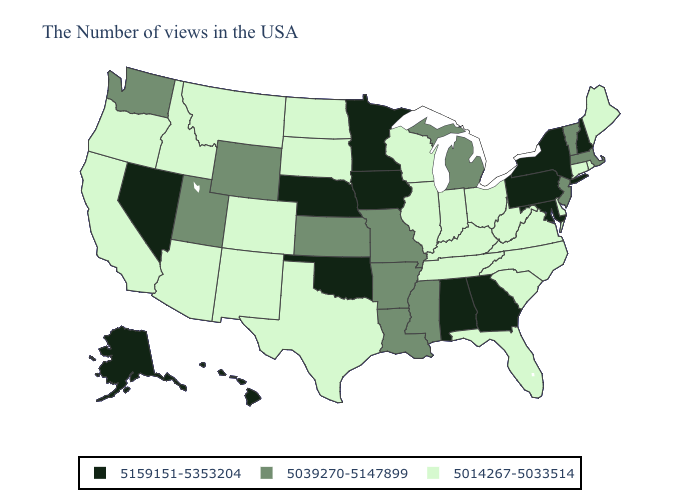Among the states that border Delaware , does Pennsylvania have the highest value?
Be succinct. Yes. Does the first symbol in the legend represent the smallest category?
Give a very brief answer. No. What is the highest value in states that border West Virginia?
Keep it brief. 5159151-5353204. What is the lowest value in states that border Tennessee?
Short answer required. 5014267-5033514. Which states have the lowest value in the West?
Concise answer only. Colorado, New Mexico, Montana, Arizona, Idaho, California, Oregon. What is the value of Maine?
Be succinct. 5014267-5033514. Name the states that have a value in the range 5014267-5033514?
Write a very short answer. Maine, Rhode Island, Connecticut, Delaware, Virginia, North Carolina, South Carolina, West Virginia, Ohio, Florida, Kentucky, Indiana, Tennessee, Wisconsin, Illinois, Texas, South Dakota, North Dakota, Colorado, New Mexico, Montana, Arizona, Idaho, California, Oregon. Does Hawaii have the same value as West Virginia?
Quick response, please. No. Is the legend a continuous bar?
Short answer required. No. Does New Hampshire have the highest value in the Northeast?
Write a very short answer. Yes. Name the states that have a value in the range 5039270-5147899?
Concise answer only. Massachusetts, Vermont, New Jersey, Michigan, Mississippi, Louisiana, Missouri, Arkansas, Kansas, Wyoming, Utah, Washington. Name the states that have a value in the range 5039270-5147899?
Give a very brief answer. Massachusetts, Vermont, New Jersey, Michigan, Mississippi, Louisiana, Missouri, Arkansas, Kansas, Wyoming, Utah, Washington. What is the value of Vermont?
Keep it brief. 5039270-5147899. Does the map have missing data?
Write a very short answer. No. Does the first symbol in the legend represent the smallest category?
Concise answer only. No. 